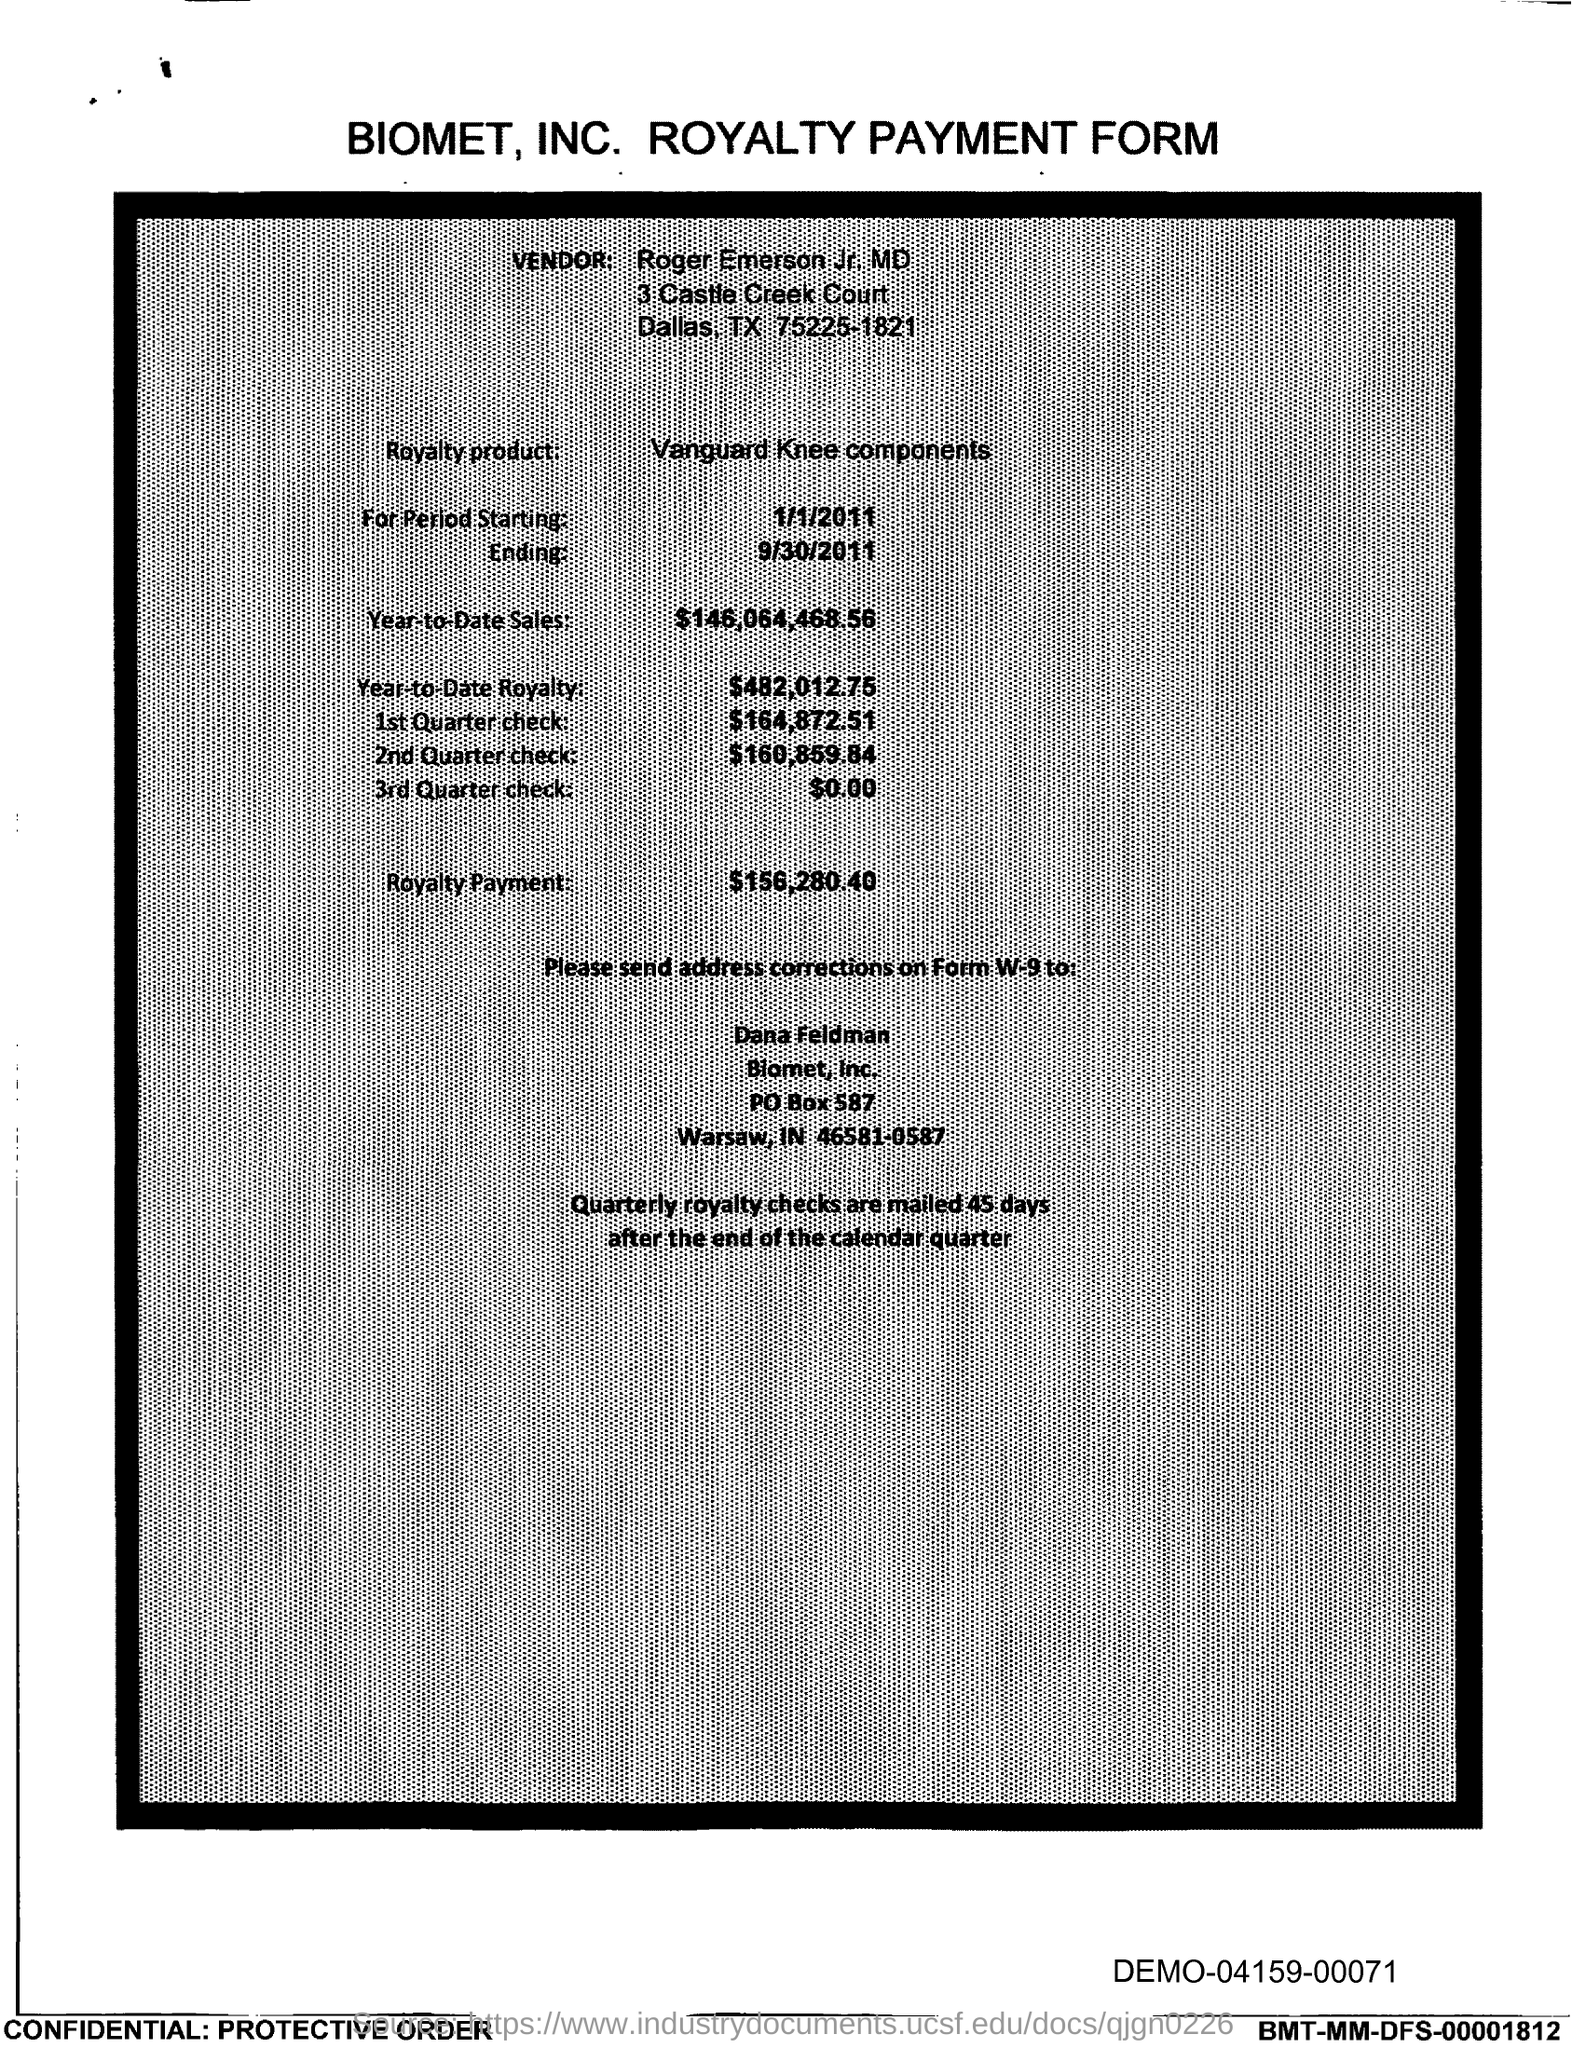Give some essential details in this illustration. What is the royalty product given in the form? It is Vanguard Knee components. The amount of the 3rd Quarter check given in the form is $0.00. Year-to-date sales of the royalty product are $146,064,468.56. The amount mentioned in the form for the 1st quarter check is $164,872.51. The royalty payment for the product mentioned in the form is $156,280.40. 